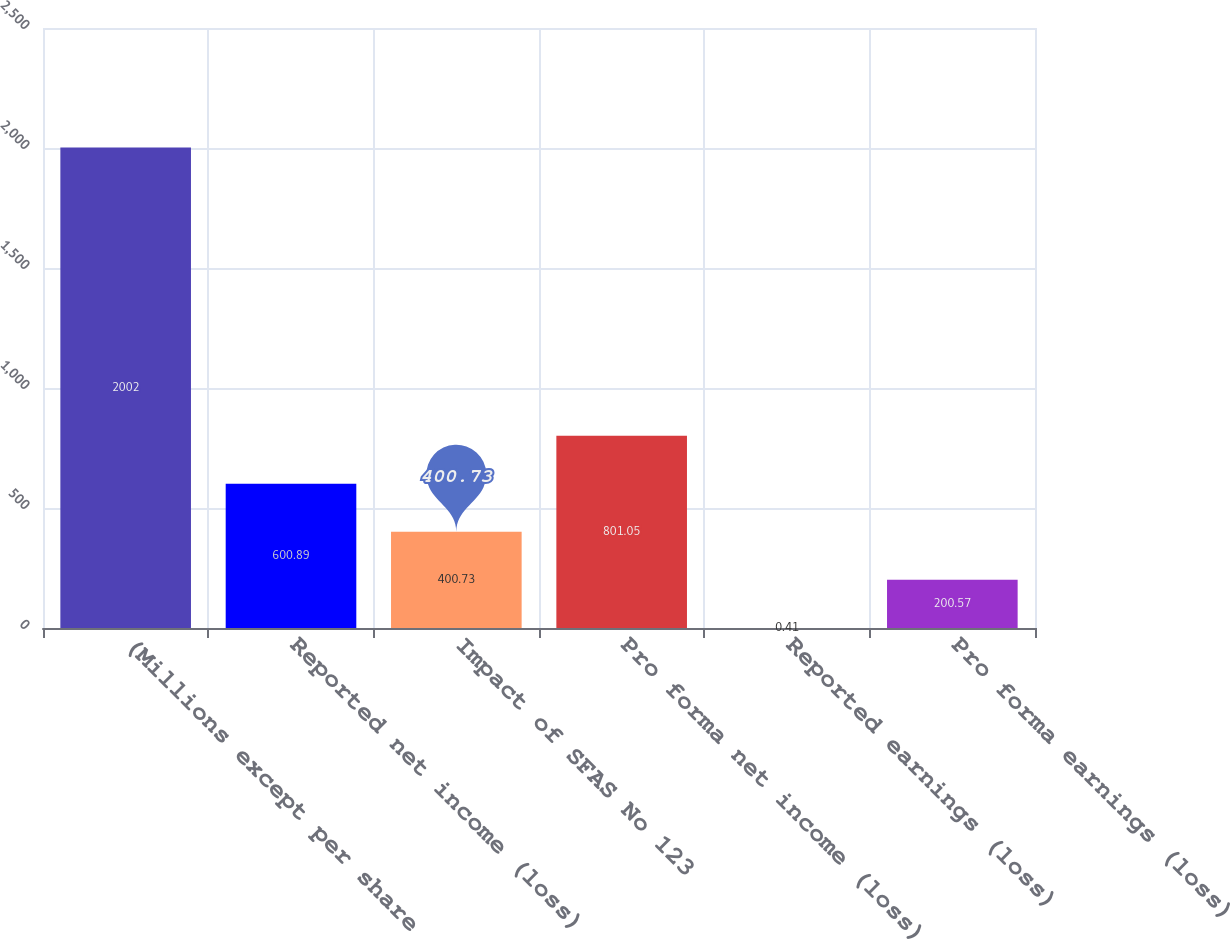<chart> <loc_0><loc_0><loc_500><loc_500><bar_chart><fcel>(Millions except per share<fcel>Reported net income (loss)<fcel>Impact of SFAS No 123<fcel>Pro forma net income (loss)<fcel>Reported earnings (loss)<fcel>Pro forma earnings (loss)<nl><fcel>2002<fcel>600.89<fcel>400.73<fcel>801.05<fcel>0.41<fcel>200.57<nl></chart> 